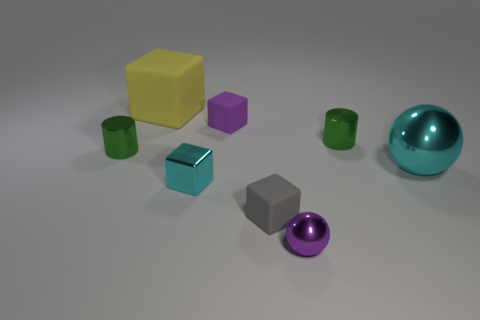Add 1 tiny shiny cylinders. How many objects exist? 9 Subtract all gray matte cubes. How many cubes are left? 3 Subtract all yellow blocks. How many blocks are left? 3 Subtract all cylinders. How many objects are left? 6 Subtract all red cubes. Subtract all green balls. How many cubes are left? 4 Add 6 large rubber objects. How many large rubber objects are left? 7 Add 4 purple cubes. How many purple cubes exist? 5 Subtract 1 purple blocks. How many objects are left? 7 Subtract all tiny cubes. Subtract all purple metal objects. How many objects are left? 4 